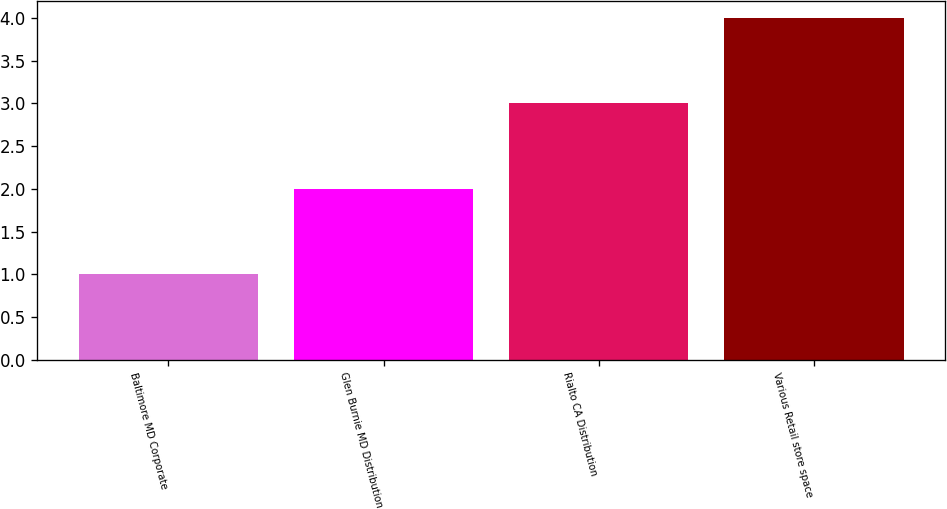Convert chart to OTSL. <chart><loc_0><loc_0><loc_500><loc_500><bar_chart><fcel>Baltimore MD Corporate<fcel>Glen Burnie MD Distribution<fcel>Rialto CA Distribution<fcel>Various Retail store space<nl><fcel>1<fcel>2<fcel>3<fcel>4<nl></chart> 